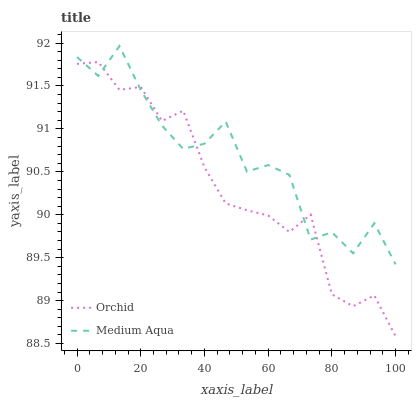Does Orchid have the minimum area under the curve?
Answer yes or no. Yes. Does Medium Aqua have the maximum area under the curve?
Answer yes or no. Yes. Does Orchid have the maximum area under the curve?
Answer yes or no. No. Is Orchid the smoothest?
Answer yes or no. Yes. Is Medium Aqua the roughest?
Answer yes or no. Yes. Is Orchid the roughest?
Answer yes or no. No. Does Orchid have the lowest value?
Answer yes or no. Yes. Does Medium Aqua have the highest value?
Answer yes or no. Yes. Does Orchid have the highest value?
Answer yes or no. No. Does Orchid intersect Medium Aqua?
Answer yes or no. Yes. Is Orchid less than Medium Aqua?
Answer yes or no. No. Is Orchid greater than Medium Aqua?
Answer yes or no. No. 